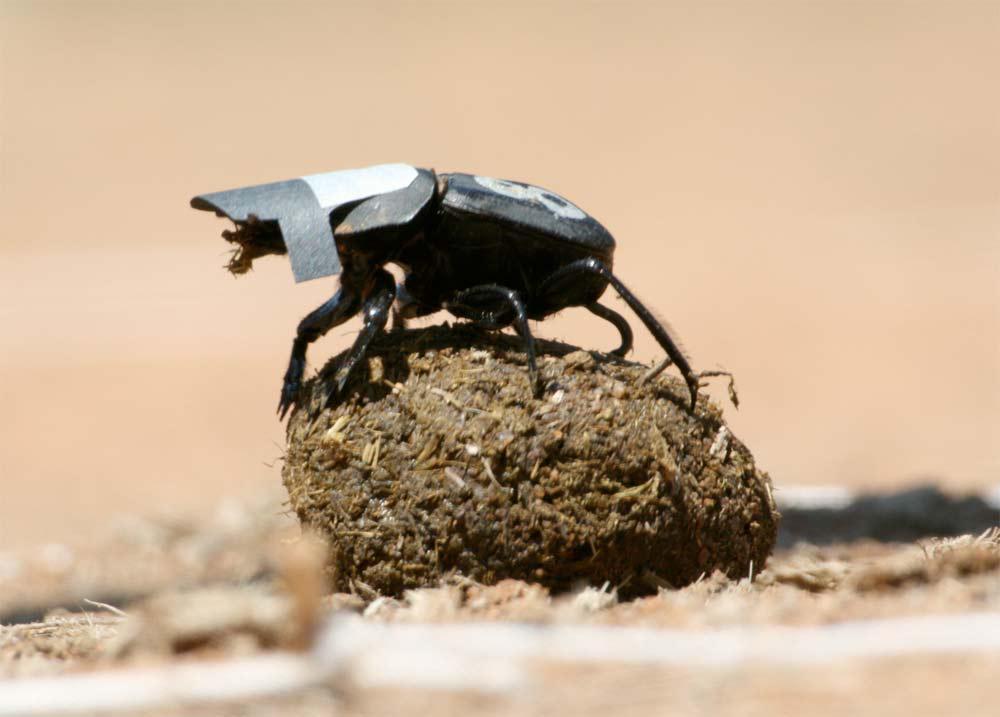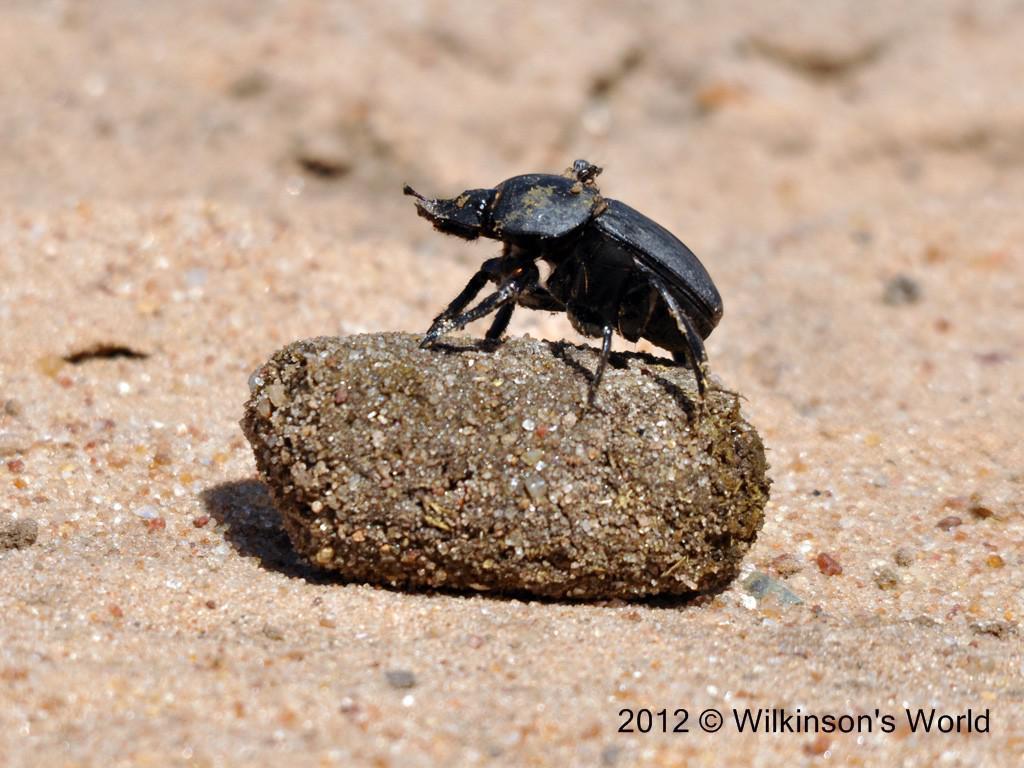The first image is the image on the left, the second image is the image on the right. Considering the images on both sides, is "At least one beetle is in contact with a round, not oblong, ball." valid? Answer yes or no. No. 